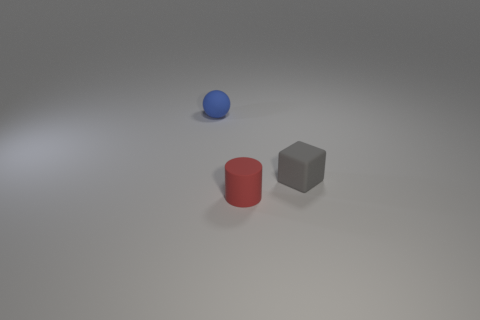Is there anything else that has the same color as the sphere?
Your response must be concise. No. The matte cube has what color?
Offer a very short reply. Gray. What number of large objects are cyan balls or gray matte blocks?
Ensure brevity in your answer.  0. How many blue objects are behind the tiny object that is in front of the small matte cube?
Your answer should be compact. 1. How many tiny blue things are the same material as the gray cube?
Provide a short and direct response. 1. Are there any matte spheres to the left of the gray matte block?
Make the answer very short. Yes. There is a sphere that is the same size as the gray block; what color is it?
Give a very brief answer. Blue. What number of things are either things behind the gray matte block or gray rubber things?
Make the answer very short. 2. There is a object that is behind the tiny red object and on the left side of the tiny gray matte cube; how big is it?
Offer a very short reply. Small. What number of other objects are there of the same size as the rubber ball?
Offer a terse response. 2. 